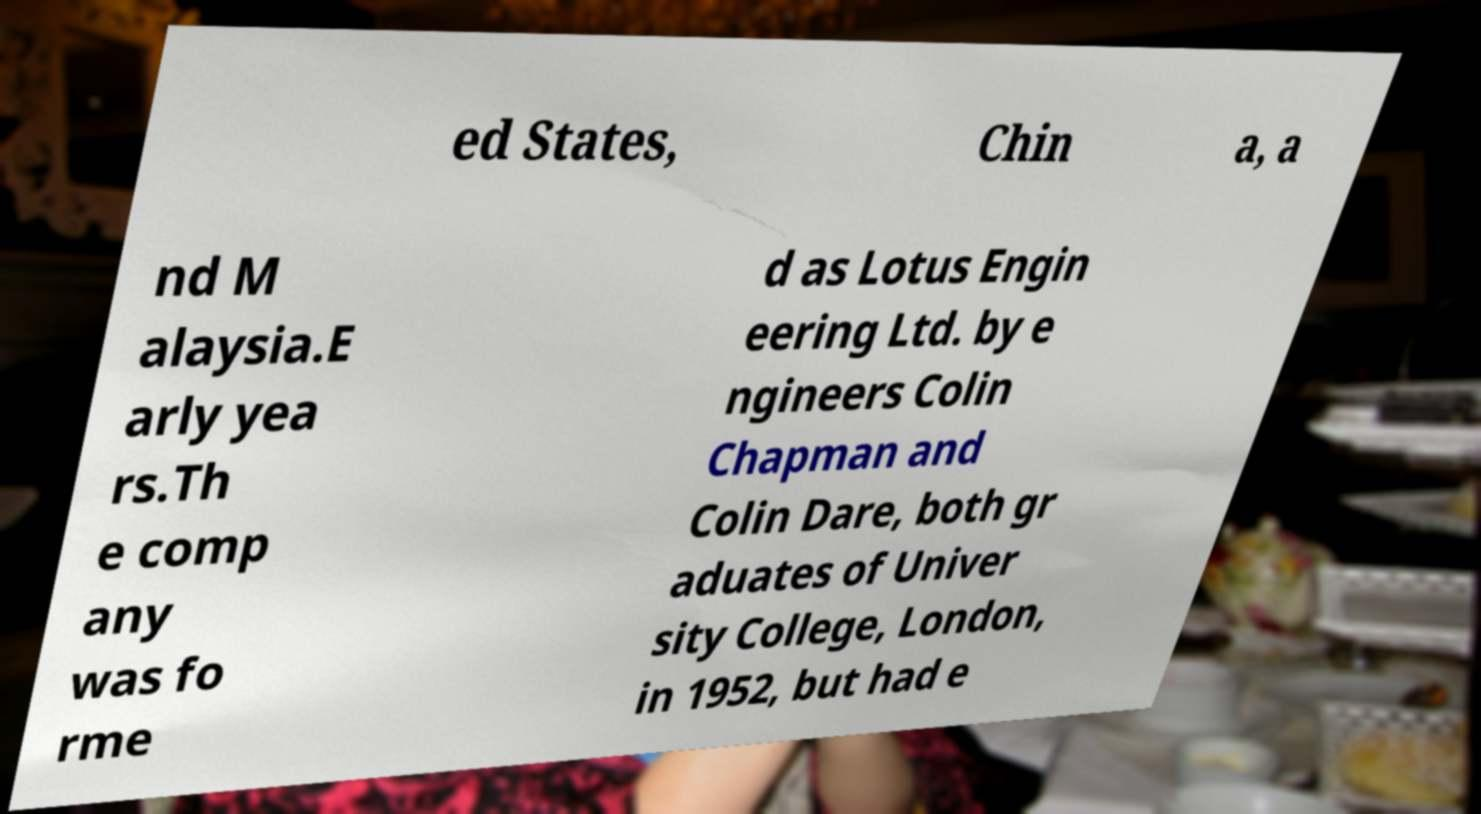For documentation purposes, I need the text within this image transcribed. Could you provide that? ed States, Chin a, a nd M alaysia.E arly yea rs.Th e comp any was fo rme d as Lotus Engin eering Ltd. by e ngineers Colin Chapman and Colin Dare, both gr aduates of Univer sity College, London, in 1952, but had e 